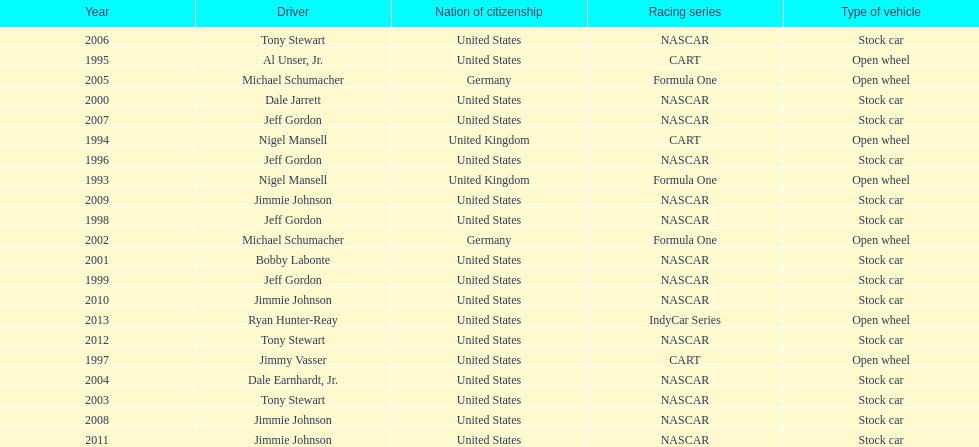How many total row entries are there? 21. 